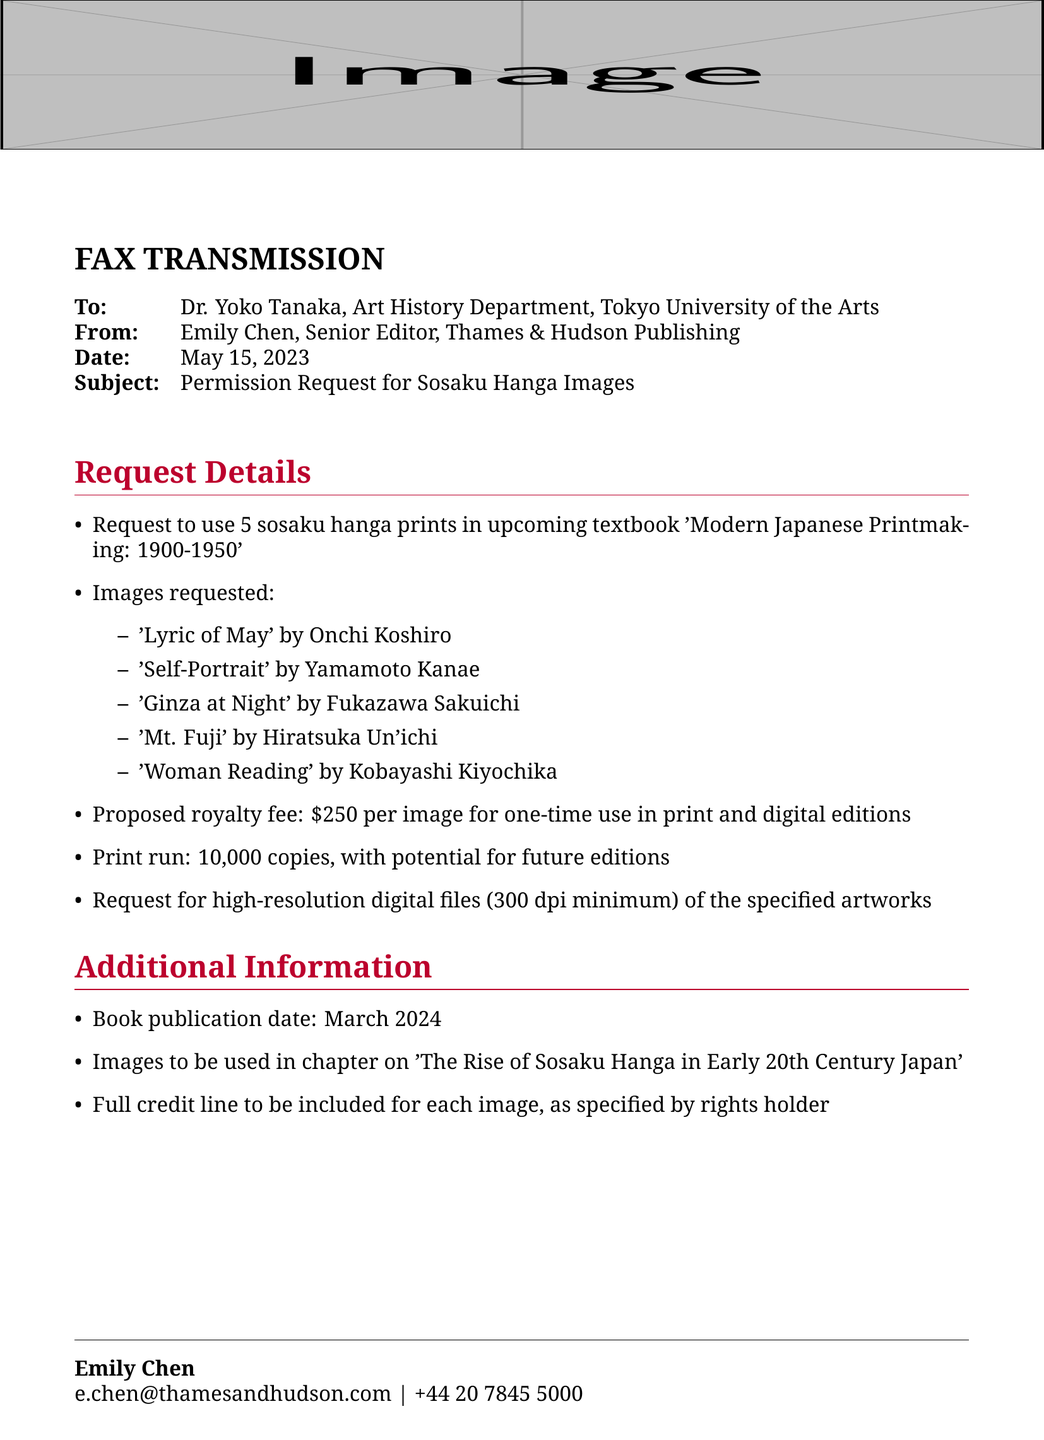What is the publisher's name? The publisher's name is mentioned in the document as the sender of the fax.
Answer: Thames & Hudson Publishing What is the subject of the fax? The subject line in the fax specifies the nature of the request being made.
Answer: Permission Request for Sosaku Hanga Images How many sosaku hanga prints are requested? The request details within the document state the number of prints needed for the textbook.
Answer: 5 What is the proposed royalty fee per image? The proposed royalty fee is clearly stated in the request details section of the document.
Answer: $250 What is the publication date of the textbook? The book publication date is provided in the additional information section of the document.
Answer: March 2024 Which image is by Onchi Koshiro? One of the images listed in the request includes the artist's name associated with the artwork.
Answer: 'Lyric of May' Why is high-resolution digital files requested? This request is implied in the rationale for using the images in the textbook.
Answer: For print and digital editions What is the print run for the upcoming textbook? The print run is a specific detail mentioned in the request details section of the document.
Answer: 10,000 copies What chapter will the images be used in? The chapter title is specified in the additional information section regarding the content of the textbook.
Answer: The Rise of Sosaku Hanga in Early 20th Century Japan 